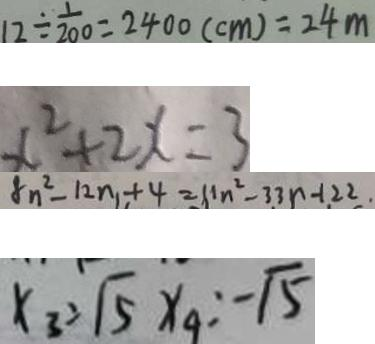Convert formula to latex. <formula><loc_0><loc_0><loc_500><loc_500>1 2 \div \frac { 1 } { 2 0 0 } = 2 4 0 0 ( c m ) = 2 4 m 
 x ^ { 2 } + 2 x = 3 
 8 n ^ { 2 } - 1 2 n + 4 = 1 1 n ^ { 2 } - 3 3 n - 1 2 2 
 x _ { 3 } = \sqrt { 5 } x _ { 4 } = - \sqrt { 5 }</formula> 